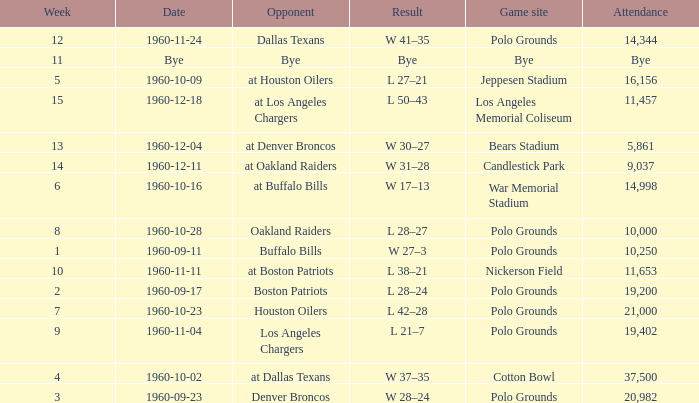What day had 37,500 attending? 1960-10-02. 